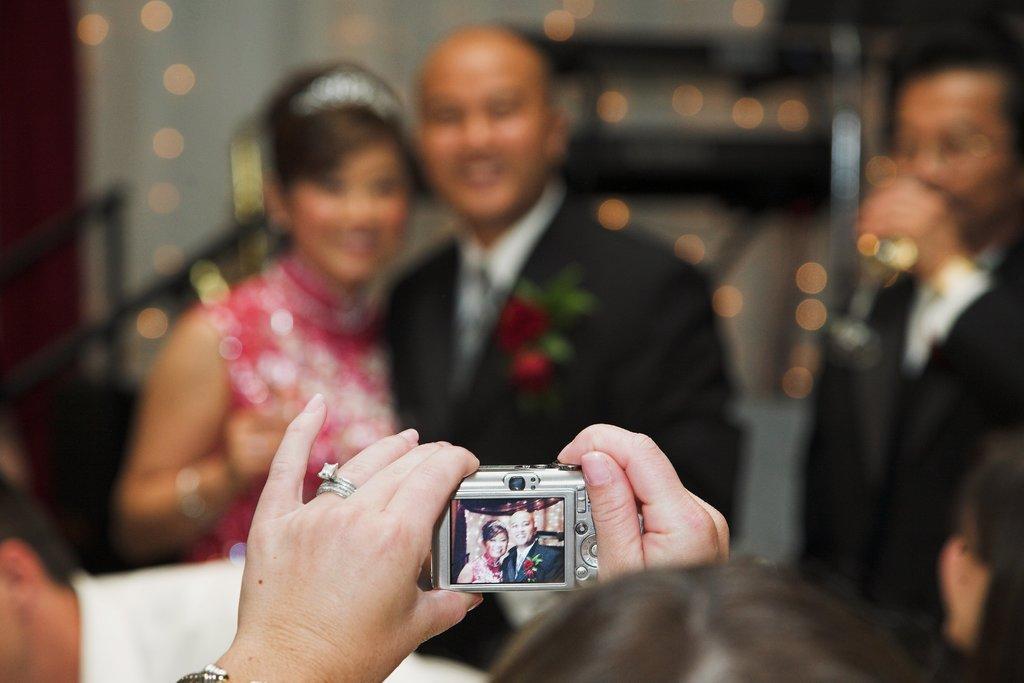Can you describe this image briefly? a person is holding a camera taking a picture of 2 people. at the right a person is standing. at the center there are 2 people. the person at the left is wearing a crown and the person at the right is wearing the suit. 